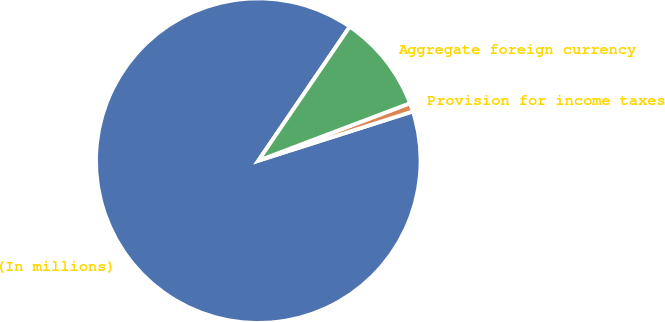<chart> <loc_0><loc_0><loc_500><loc_500><pie_chart><fcel>(In millions)<fcel>Provision for income taxes<fcel>Aggregate foreign currency<nl><fcel>89.45%<fcel>0.85%<fcel>9.71%<nl></chart> 